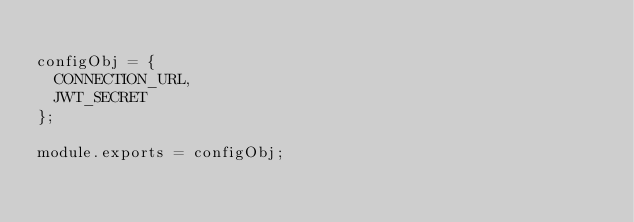<code> <loc_0><loc_0><loc_500><loc_500><_JavaScript_>
configObj = {
  CONNECTION_URL,
  JWT_SECRET
};

module.exports = configObj;</code> 